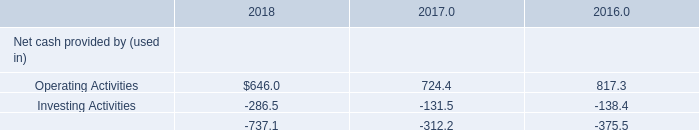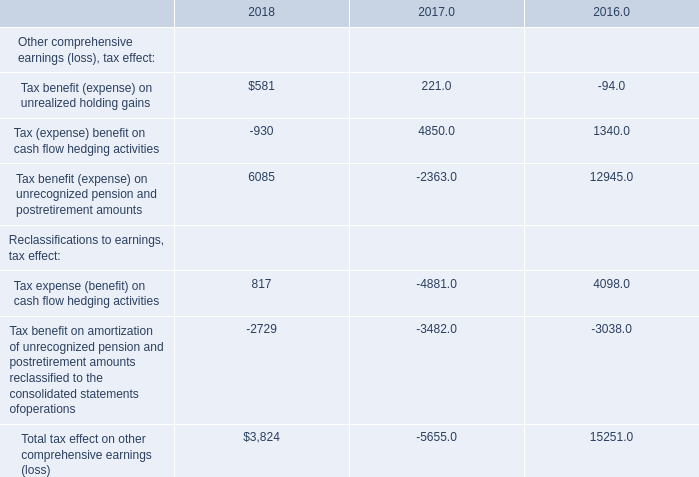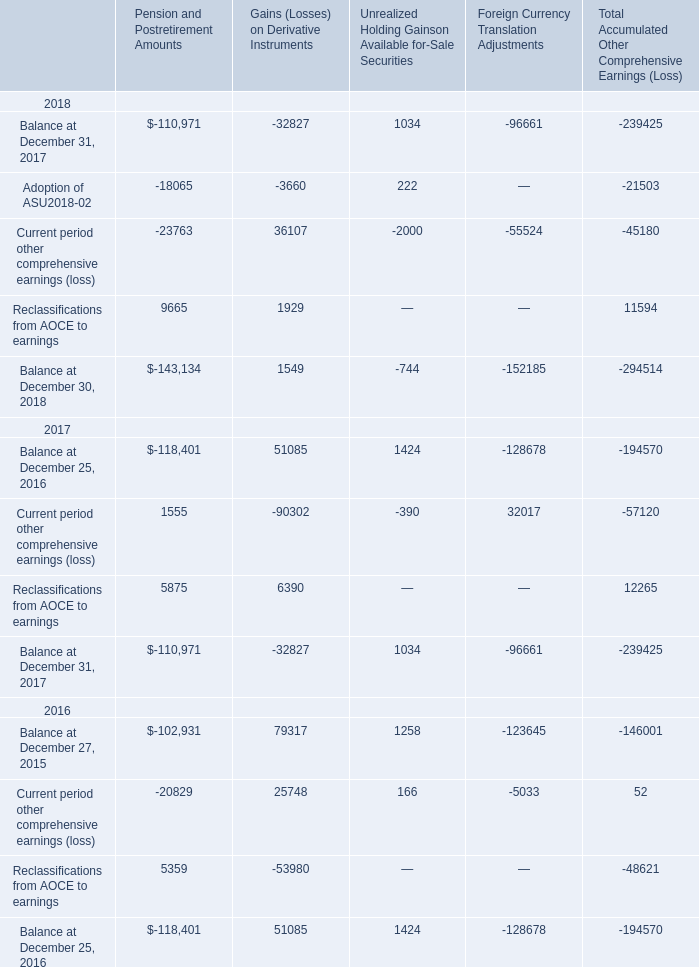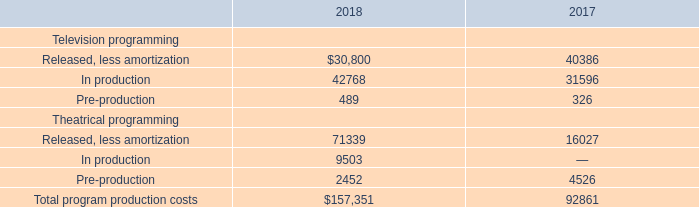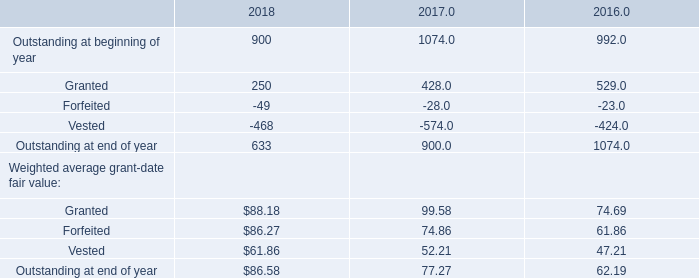Which year is Tax benefit (expense) on unrealized holding gains the most? 
Answer: 2018. 